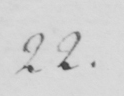Please provide the text content of this handwritten line. 22 . 